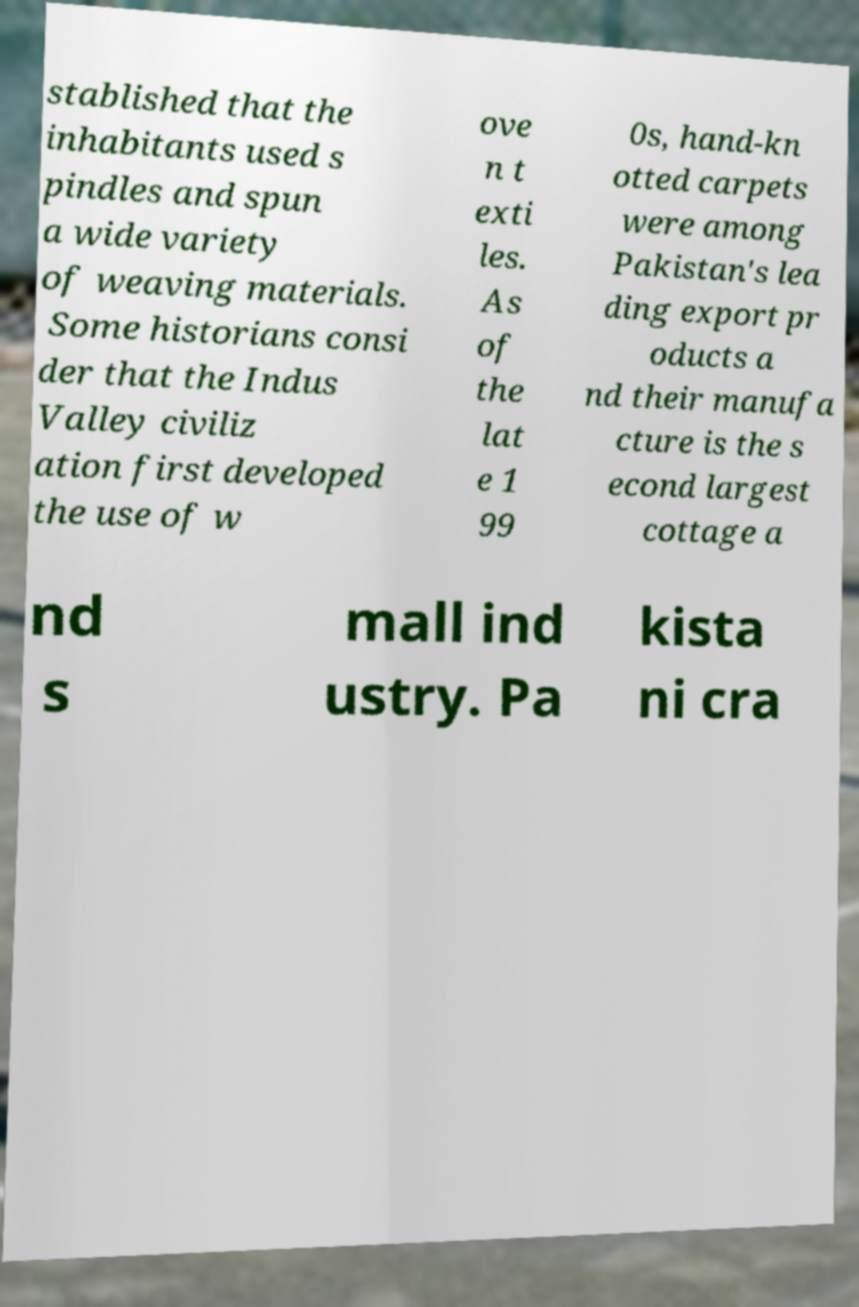I need the written content from this picture converted into text. Can you do that? stablished that the inhabitants used s pindles and spun a wide variety of weaving materials. Some historians consi der that the Indus Valley civiliz ation first developed the use of w ove n t exti les. As of the lat e 1 99 0s, hand-kn otted carpets were among Pakistan's lea ding export pr oducts a nd their manufa cture is the s econd largest cottage a nd s mall ind ustry. Pa kista ni cra 